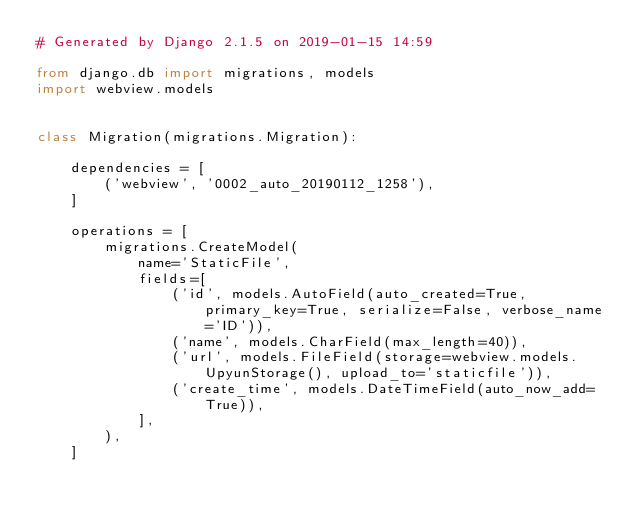Convert code to text. <code><loc_0><loc_0><loc_500><loc_500><_Python_># Generated by Django 2.1.5 on 2019-01-15 14:59

from django.db import migrations, models
import webview.models


class Migration(migrations.Migration):

    dependencies = [
        ('webview', '0002_auto_20190112_1258'),
    ]

    operations = [
        migrations.CreateModel(
            name='StaticFile',
            fields=[
                ('id', models.AutoField(auto_created=True, primary_key=True, serialize=False, verbose_name='ID')),
                ('name', models.CharField(max_length=40)),
                ('url', models.FileField(storage=webview.models.UpyunStorage(), upload_to='staticfile')),
                ('create_time', models.DateTimeField(auto_now_add=True)),
            ],
        ),
    ]
</code> 